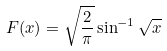Convert formula to latex. <formula><loc_0><loc_0><loc_500><loc_500>F ( x ) = \sqrt { \frac { 2 } { \pi } } \sin ^ { - 1 } \sqrt { x }</formula> 